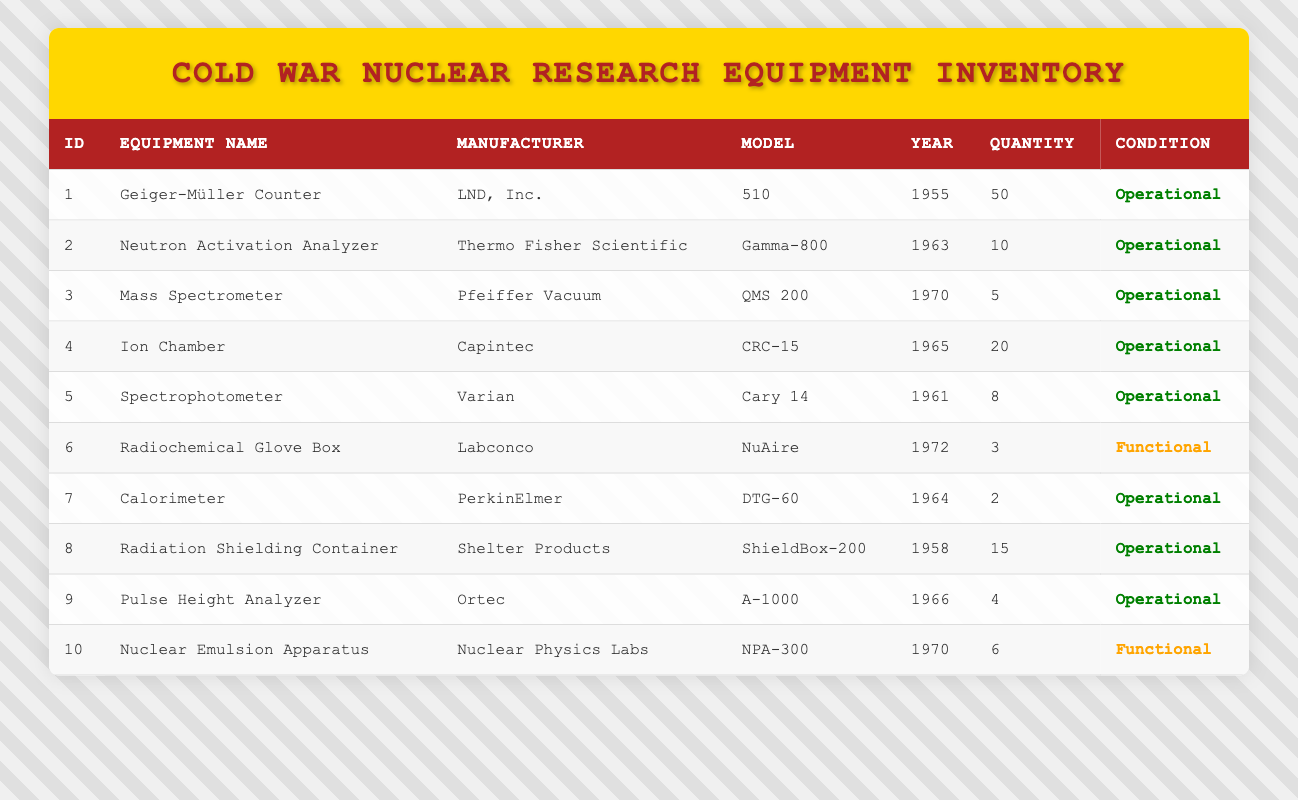What is the total quantity of Geiger-Müller Counters available? There are 50 Geiger-Müller Counters listed in the table under the quantity column.
Answer: 50 How many pieces of equipment were manufactured after 1965? The equipment manufactured after 1965 are the Neutron Activation Analyzer (1963), Mass Spectrometer (1970), Radiochemical Glove Box (1972), and Nuclear Emulsion Apparatus (1970). Counting these gives 6 pieces of equipment.
Answer: 6 Is the Ion Chamber operational? The condition of the Ion Chamber is listed as "Operational" in the table.
Answer: Yes What is the range of years for the equipment listed? The earliest equipment was manufactured in 1955 (Geiger-Müller Counter) and the latest in 1972 (Radiochemical Glove Box). Therefore, the range is from 1955 to 1972.
Answer: 1955 to 1972 How many pieces of equipment are categorized as functional? Only the Radiochemical Glove Box and Nuclear Emulsion Apparatus are labeled as functional, giving a total of 3 pieces.
Answer: 2 Which equipment has the highest quantity, and what is that quantity? The Geiger-Müller Counter has the highest quantity listed at 50 units, while all other equipment have lower quantities.
Answer: 50 What percentage of the total inventory is operational equipment? Summing the quantities of operational equipment gives (50 + 10 + 5 + 20 + 8 + 2 + 15 + 4) = 114. The total quantity of all equipment is 50 + 10 + 5 + 20 + 8 + 3 + 2 + 15 + 4 + 6 = 123. The percentage is (114/123) * 100 = 92.68%.
Answer: 92.68% Is there any equipment manufactured in 1964? The Calorimeter is listed with a manufacturing year of 1964, confirming that there is equipment from that year.
Answer: Yes How many different manufacturers are represented in the inventory table? The manufacturers listed are LND, Thermo Fisher Scientific, Pfeiffer Vacuum, Capintec, Varian, Labconco, PerkinElmer, Shelter Products, Ortec, and Nuclear Physics Labs, totaling 10 different manufacturers.
Answer: 10 